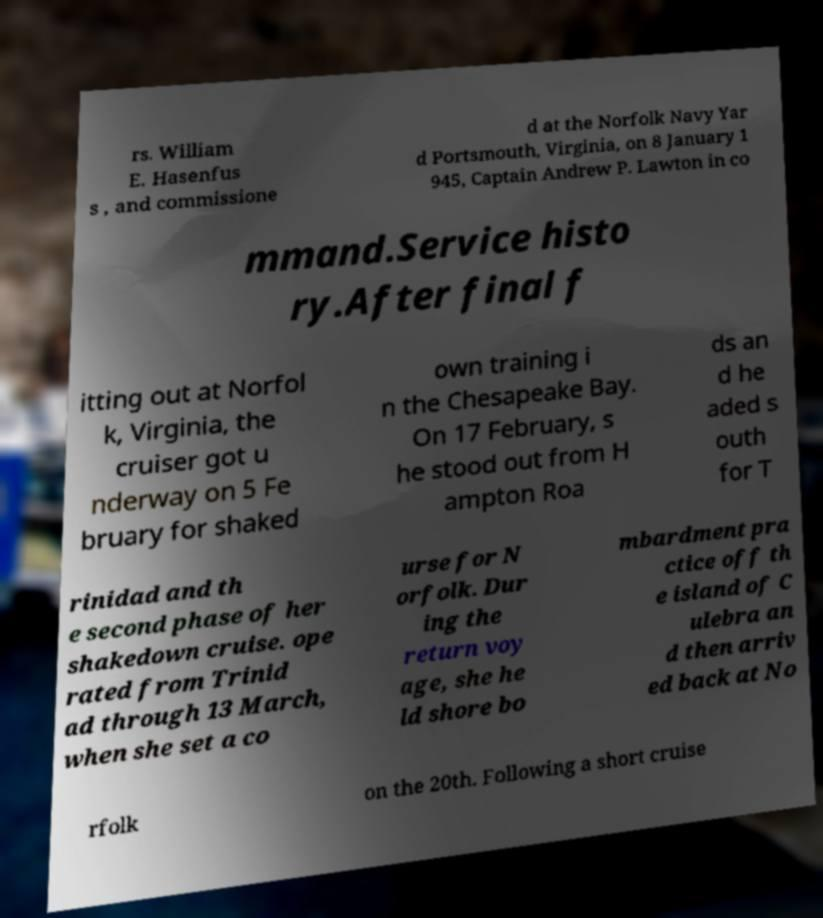Please read and relay the text visible in this image. What does it say? rs. William E. Hasenfus s , and commissione d at the Norfolk Navy Yar d Portsmouth, Virginia, on 8 January 1 945, Captain Andrew P. Lawton in co mmand.Service histo ry.After final f itting out at Norfol k, Virginia, the cruiser got u nderway on 5 Fe bruary for shaked own training i n the Chesapeake Bay. On 17 February, s he stood out from H ampton Roa ds an d he aded s outh for T rinidad and th e second phase of her shakedown cruise. ope rated from Trinid ad through 13 March, when she set a co urse for N orfolk. Dur ing the return voy age, she he ld shore bo mbardment pra ctice off th e island of C ulebra an d then arriv ed back at No rfolk on the 20th. Following a short cruise 